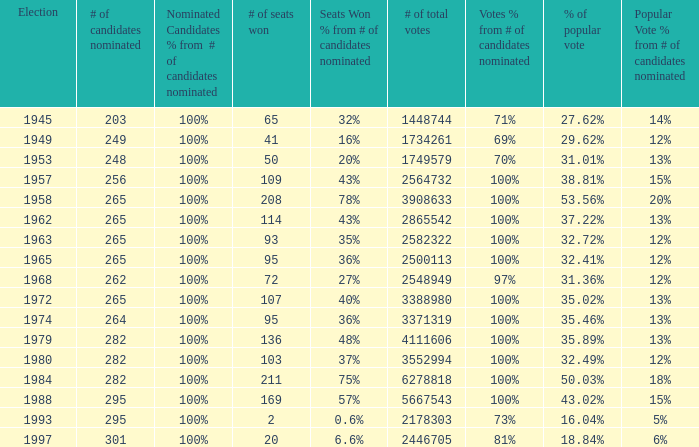What was the lowest # of total votes? 1448744.0. 